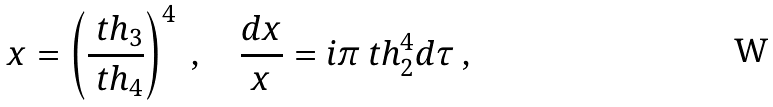Convert formula to latex. <formula><loc_0><loc_0><loc_500><loc_500>x = \left ( \frac { \ t h _ { 3 } } { \ t h _ { 4 } } \right ) ^ { 4 } \ , \quad \frac { d x } { x } = i \pi \ t h _ { 2 } ^ { 4 } d \tau \ ,</formula> 